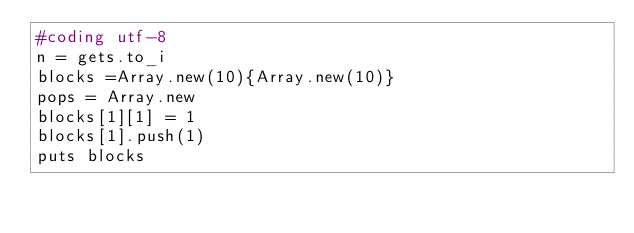<code> <loc_0><loc_0><loc_500><loc_500><_Ruby_>#coding utf-8
n = gets.to_i
blocks =Array.new(10){Array.new(10)}
pops = Array.new
blocks[1][1] = 1
blocks[1].push(1)
puts blocks</code> 